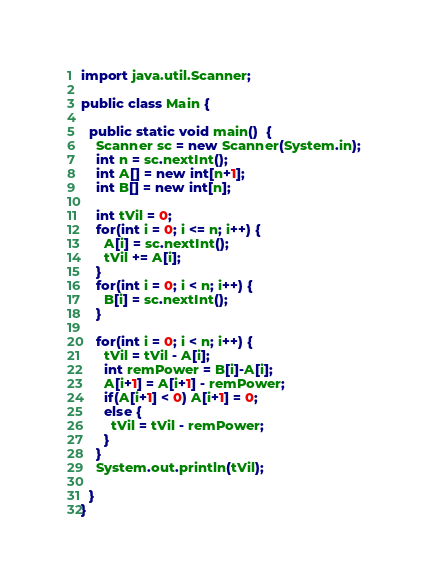<code> <loc_0><loc_0><loc_500><loc_500><_Java_>import java.util.Scanner;
 
public class Main {
  
  public static void main()  {
    Scanner sc = new Scanner(System.in);
    int n = sc.nextInt();
    int A[] = new int[n+1];
    int B[] = new int[n];
    
    int tVil = 0;
    for(int i = 0; i <= n; i++) {
      A[i] = sc.nextInt();
      tVil += A[i];
    }
    for(int i = 0; i < n; i++) {
      B[i] = sc.nextInt();
    }
    
    for(int i = 0; i < n; i++) {
      tVil = tVil - A[i];
      int remPower = B[i]-A[i];
      A[i+1] = A[i+1] - remPower;
      if(A[i+1] < 0) A[i+1] = 0;
      else {
        tVil = tVil - remPower;
      }
    }
    System.out.println(tVil);
    
  }
}</code> 